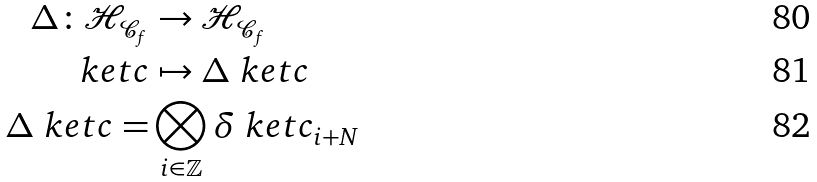<formula> <loc_0><loc_0><loc_500><loc_500>\Delta \colon \mathcal { H } _ { \mathcal { C } _ { f } } & \rightarrow \mathcal { H } _ { \mathcal { C } _ { f } } \\ \ k e t { c } & \mapsto \Delta \ k e t { c } \\ \Delta \ k e t { c } = & \bigotimes _ { i \in \mathbb { Z } } \delta \ k e t { c _ { i + N } }</formula> 